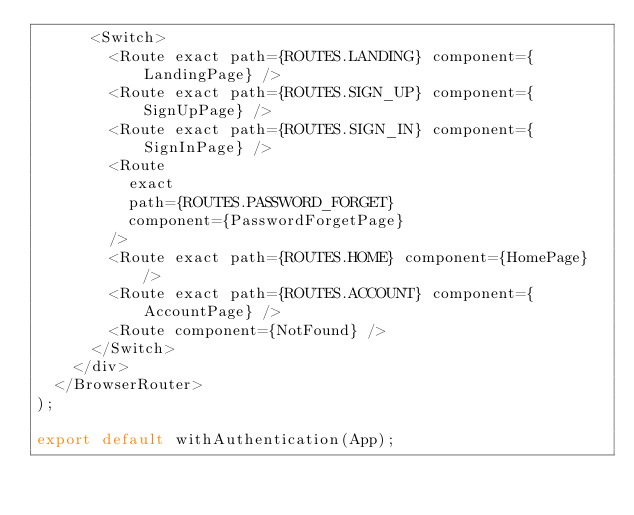<code> <loc_0><loc_0><loc_500><loc_500><_TypeScript_>      <Switch>
        <Route exact path={ROUTES.LANDING} component={LandingPage} />
        <Route exact path={ROUTES.SIGN_UP} component={SignUpPage} />
        <Route exact path={ROUTES.SIGN_IN} component={SignInPage} />
        <Route
          exact
          path={ROUTES.PASSWORD_FORGET}
          component={PasswordForgetPage}
        />
        <Route exact path={ROUTES.HOME} component={HomePage} />
        <Route exact path={ROUTES.ACCOUNT} component={AccountPage} />
        <Route component={NotFound} />
      </Switch>
    </div>
  </BrowserRouter>
);

export default withAuthentication(App);
</code> 